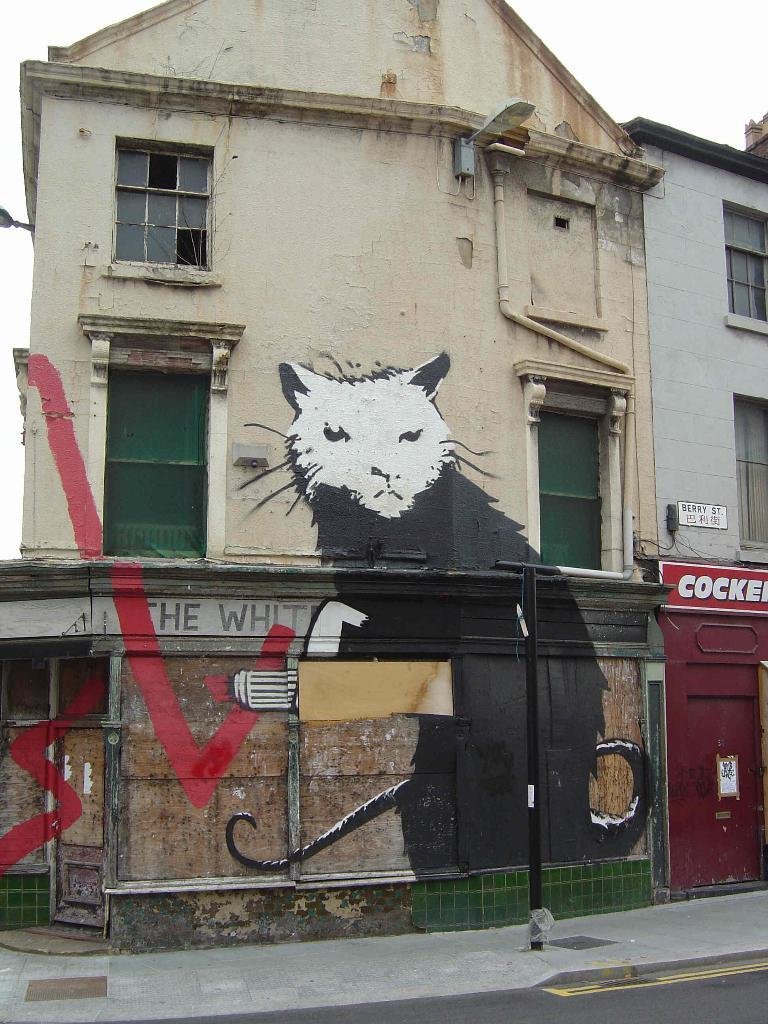What type of surface can be seen in the image? There is a road in the image. What can be found on a vertical surface in the image? There is art on a wall in the image. What type of structure is present in the image? There is a building in the image. What object can be seen in the image that might be used for displaying information or announcements? There is a board in the image. What is visible in the background of the image? The sky is visible in the background of the image. What type of soup is being served at the club in the image? There is no soup or club present in the image. What sense is being stimulated by the art on the wall in the image? The provided facts do not mention any specific sensory experience related to the art on the wall, so it cannot be determined which sense is being stimulated. 